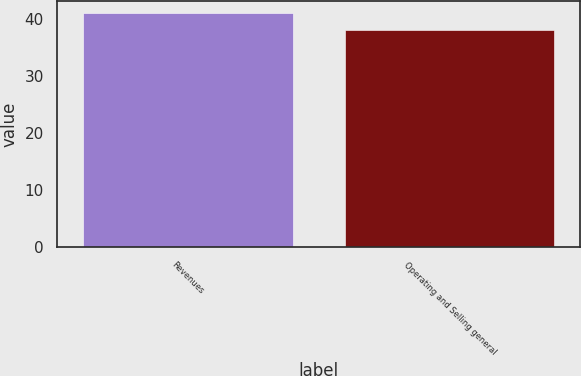Convert chart. <chart><loc_0><loc_0><loc_500><loc_500><bar_chart><fcel>Revenues<fcel>Operating and Selling general<nl><fcel>41<fcel>38<nl></chart> 